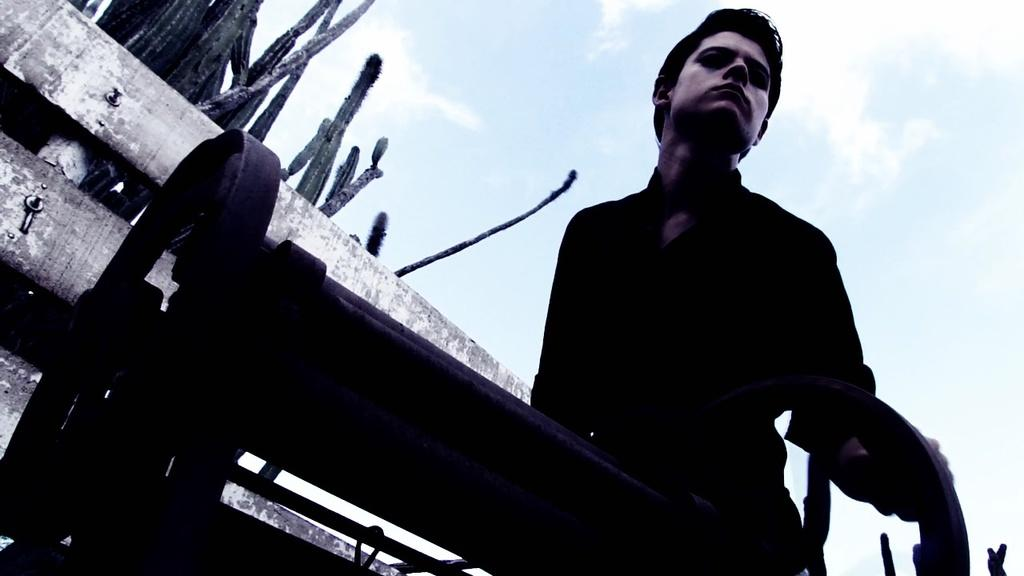Who or what is present in the image? There is a person in the image. What can be seen attached to the person or nearby? There are wheels in the image. What type of material is visible in the background? There are wooden sticks in the background of the image. What is visible in the distance behind the person and the wooden sticks? The sky is visible in the background of the image. What type of brass instrument is being played by the person in the image? There is no brass instrument present in the image; the person is not playing any musical instrument. 